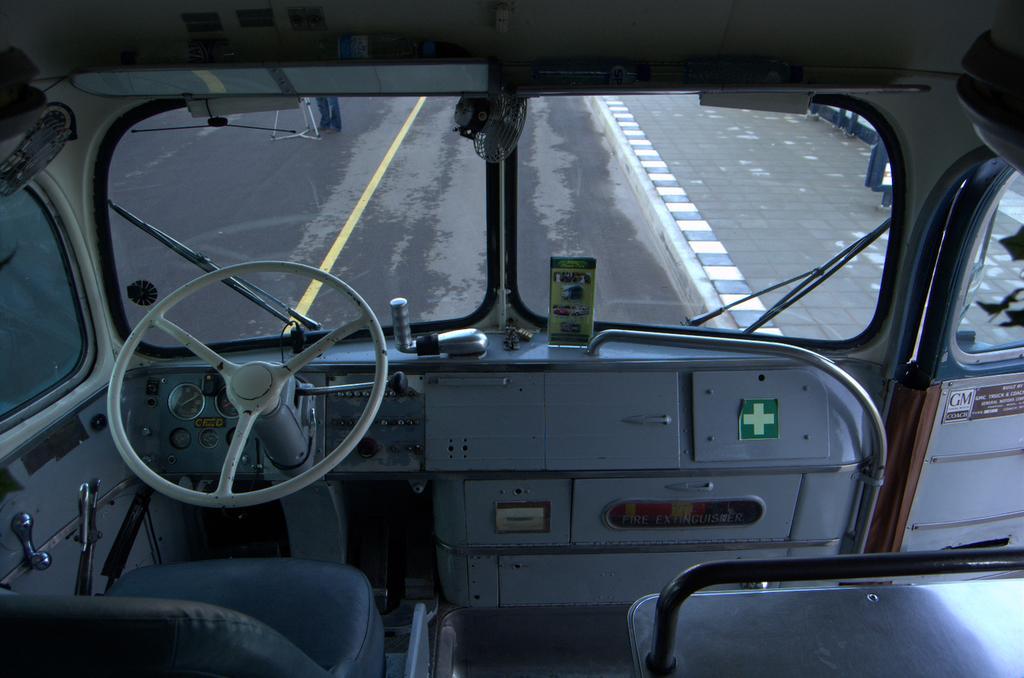Can you describe this image briefly? This picture is clicked inside the vehicle. In this picture, we see seats and a steering wheel. In front of that, we see wipers and a front glass of the vehicle from which we can see the road. On the right side, we see the footpath. 